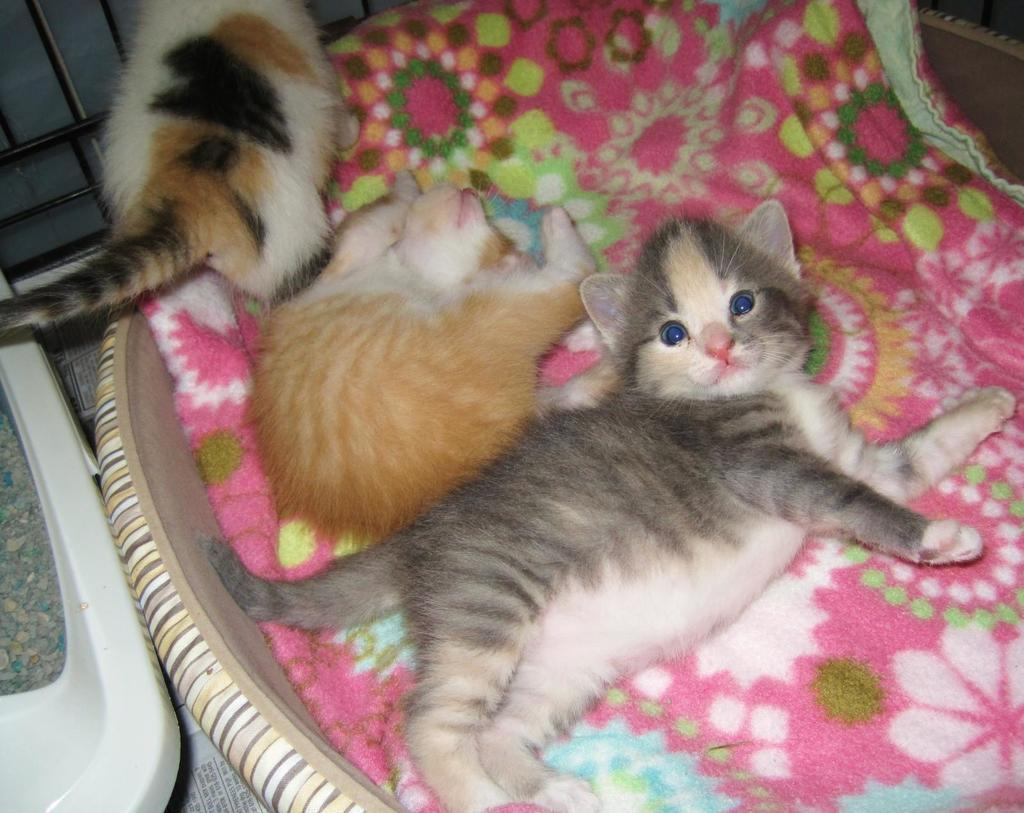How many kittens are present in the image? There are three kittens in the image. Can you describe the size of the kittens? The kittens are small. Where are the kittens located in the image? The kittens are sitting in a basket. What type of trick can be seen performed by the kittens in the image? There is no trick being performed by the kittens in the image; they are simply sitting in a basket. 